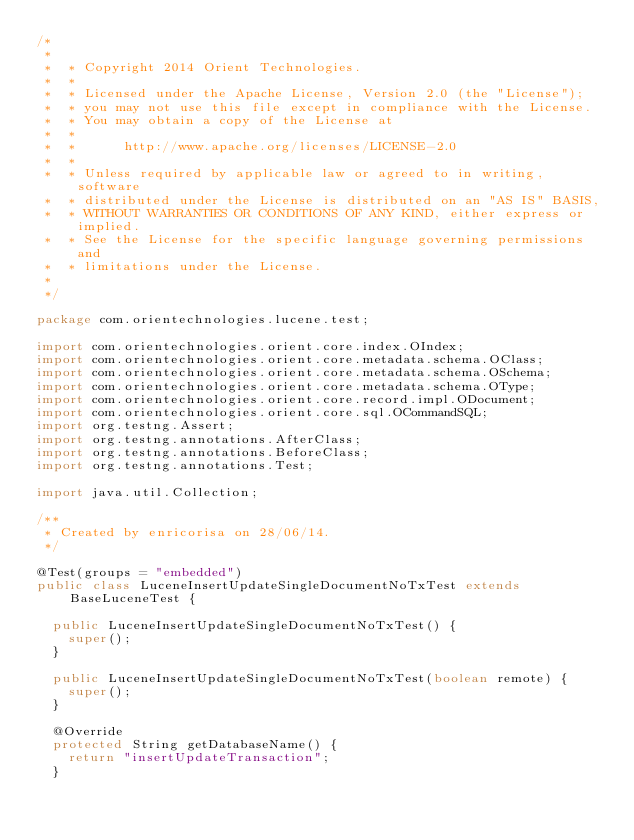Convert code to text. <code><loc_0><loc_0><loc_500><loc_500><_Java_>/*
 *
 *  * Copyright 2014 Orient Technologies.
 *  *
 *  * Licensed under the Apache License, Version 2.0 (the "License");
 *  * you may not use this file except in compliance with the License.
 *  * You may obtain a copy of the License at
 *  *
 *  *      http://www.apache.org/licenses/LICENSE-2.0
 *  *
 *  * Unless required by applicable law or agreed to in writing, software
 *  * distributed under the License is distributed on an "AS IS" BASIS,
 *  * WITHOUT WARRANTIES OR CONDITIONS OF ANY KIND, either express or implied.
 *  * See the License for the specific language governing permissions and
 *  * limitations under the License.
 *  
 */

package com.orientechnologies.lucene.test;

import com.orientechnologies.orient.core.index.OIndex;
import com.orientechnologies.orient.core.metadata.schema.OClass;
import com.orientechnologies.orient.core.metadata.schema.OSchema;
import com.orientechnologies.orient.core.metadata.schema.OType;
import com.orientechnologies.orient.core.record.impl.ODocument;
import com.orientechnologies.orient.core.sql.OCommandSQL;
import org.testng.Assert;
import org.testng.annotations.AfterClass;
import org.testng.annotations.BeforeClass;
import org.testng.annotations.Test;

import java.util.Collection;

/**
 * Created by enricorisa on 28/06/14.
 */

@Test(groups = "embedded")
public class LuceneInsertUpdateSingleDocumentNoTxTest extends BaseLuceneTest {

  public LuceneInsertUpdateSingleDocumentNoTxTest() {
    super();
  }

  public LuceneInsertUpdateSingleDocumentNoTxTest(boolean remote) {
    super();
  }

  @Override
  protected String getDatabaseName() {
    return "insertUpdateTransaction";
  }
</code> 